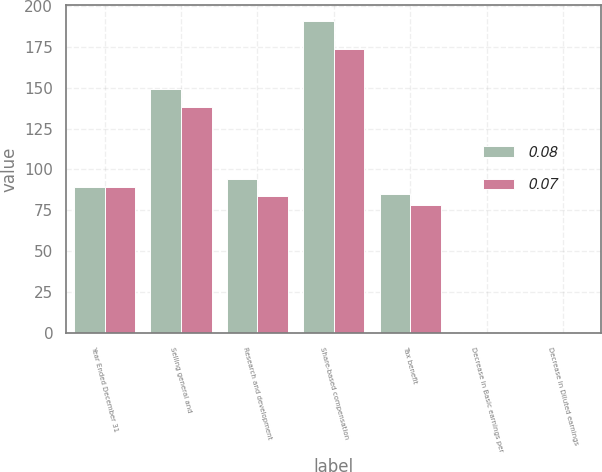Convert chart. <chart><loc_0><loc_0><loc_500><loc_500><stacked_bar_chart><ecel><fcel>Year Ended December 31<fcel>Selling general and<fcel>Research and development<fcel>Share-based compensation<fcel>Tax benefit<fcel>Decrease in Basic earnings per<fcel>Decrease in Diluted earnings<nl><fcel>0.08<fcel>89.5<fcel>149<fcel>94<fcel>191<fcel>85<fcel>0.08<fcel>0.08<nl><fcel>0.07<fcel>89.5<fcel>138<fcel>84<fcel>174<fcel>78<fcel>0.07<fcel>0.07<nl></chart> 